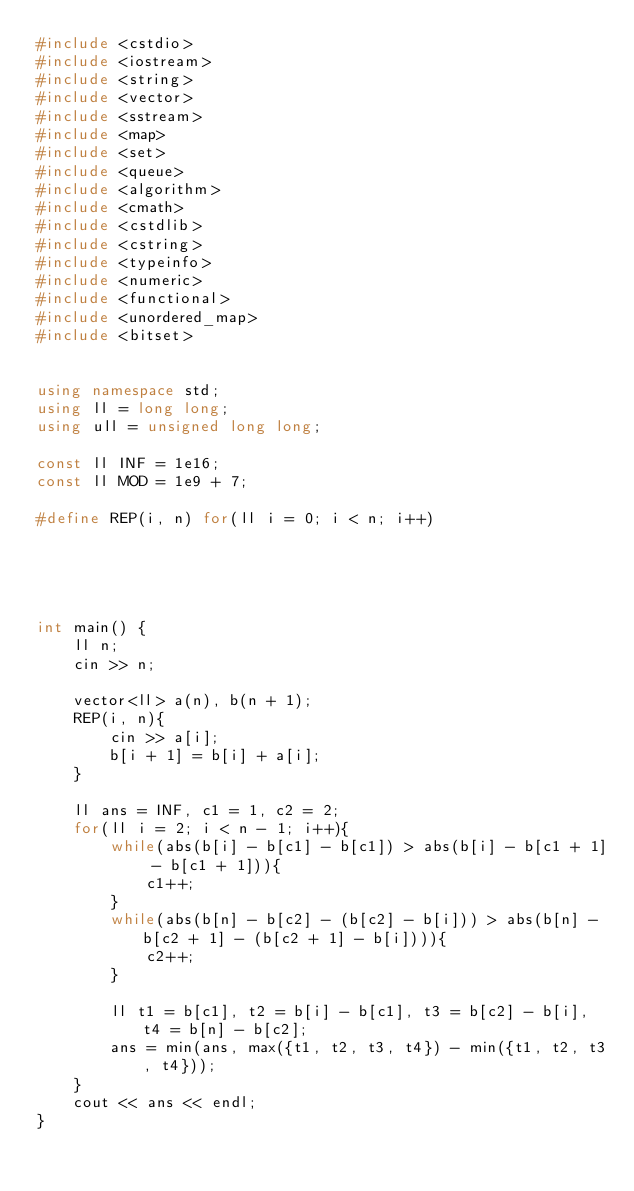<code> <loc_0><loc_0><loc_500><loc_500><_C++_>#include <cstdio>
#include <iostream>
#include <string>
#include <vector>
#include <sstream>
#include <map>
#include <set>
#include <queue>
#include <algorithm>
#include <cmath>
#include <cstdlib>
#include <cstring>
#include <typeinfo>
#include <numeric>
#include <functional>
#include <unordered_map>
#include <bitset>


using namespace std;
using ll = long long;
using ull = unsigned long long;

const ll INF = 1e16;
const ll MOD = 1e9 + 7;

#define REP(i, n) for(ll i = 0; i < n; i++)





int main() {
    ll n;
    cin >> n;
    
    vector<ll> a(n), b(n + 1);
    REP(i, n){
        cin >> a[i];
        b[i + 1] = b[i] + a[i];
    }
    
    ll ans = INF, c1 = 1, c2 = 2;
    for(ll i = 2; i < n - 1; i++){
        while(abs(b[i] - b[c1] - b[c1]) > abs(b[i] - b[c1 + 1] - b[c1 + 1])){
            c1++;
        }
        while(abs(b[n] - b[c2] - (b[c2] - b[i])) > abs(b[n] - b[c2 + 1] - (b[c2 + 1] - b[i]))){
            c2++;
        }
        
        ll t1 = b[c1], t2 = b[i] - b[c1], t3 = b[c2] - b[i], t4 = b[n] - b[c2];
        ans = min(ans, max({t1, t2, t3, t4}) - min({t1, t2, t3, t4}));
    }
    cout << ans << endl;
}</code> 